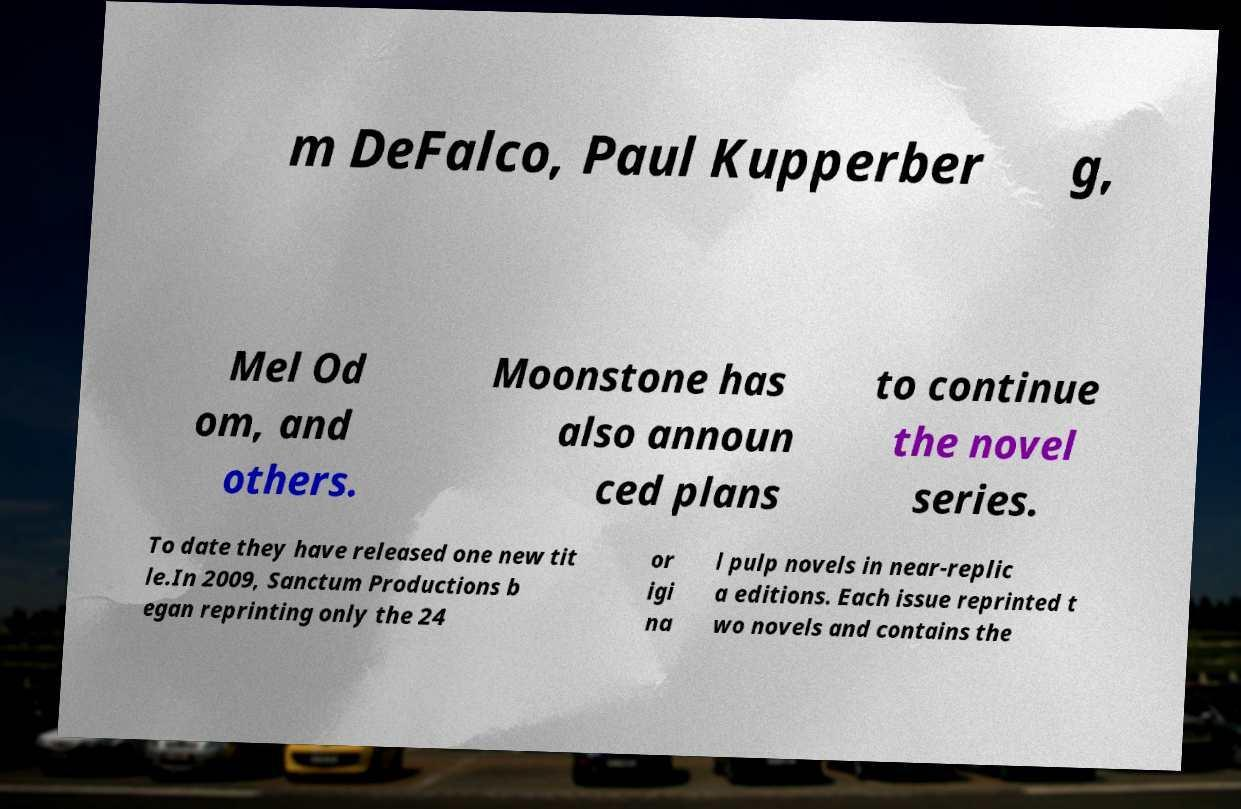Can you read and provide the text displayed in the image?This photo seems to have some interesting text. Can you extract and type it out for me? m DeFalco, Paul Kupperber g, Mel Od om, and others. Moonstone has also announ ced plans to continue the novel series. To date they have released one new tit le.In 2009, Sanctum Productions b egan reprinting only the 24 or igi na l pulp novels in near-replic a editions. Each issue reprinted t wo novels and contains the 